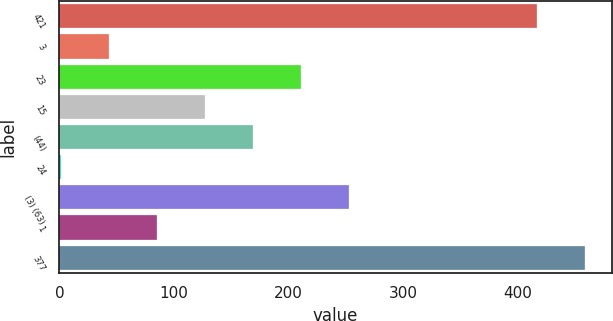Convert chart. <chart><loc_0><loc_0><loc_500><loc_500><bar_chart><fcel>421<fcel>3<fcel>23<fcel>15<fcel>(44)<fcel>24<fcel>(3) (63)<fcel>1<fcel>377<nl><fcel>417<fcel>43<fcel>211<fcel>127<fcel>169<fcel>1<fcel>253<fcel>85<fcel>459<nl></chart> 